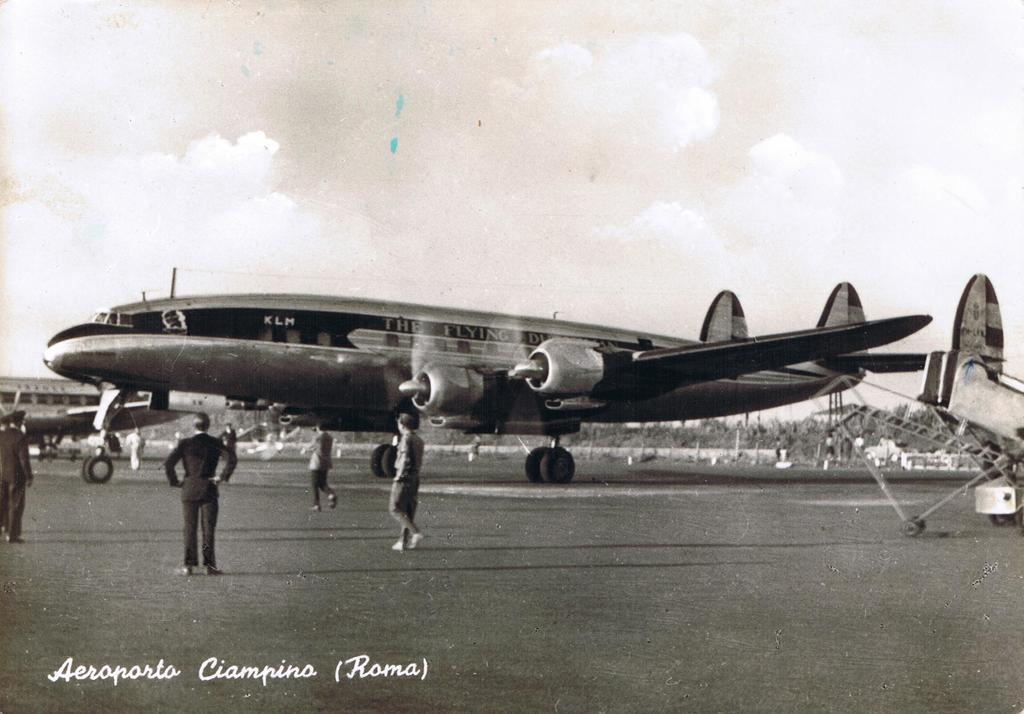Provide a one-sentence caption for the provided image. An old airplane named after the Flying Dutchman. 